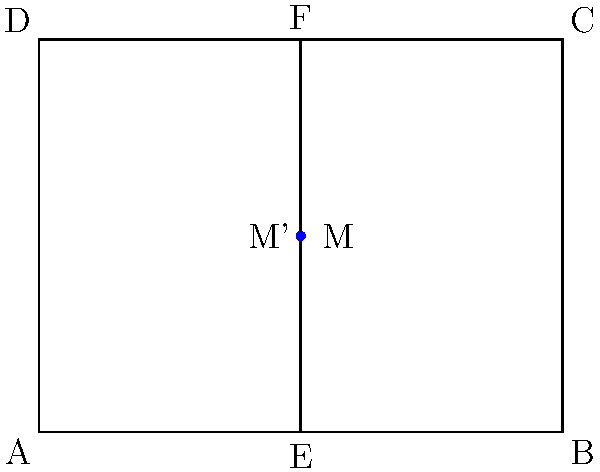A symmetric trade show logo design is represented by a rectangle ABCD with dimensions 4 units wide and 3 units tall. Point M is located at coordinates (2, 1.5) within the rectangle. If the logo is reflected across the vertical line EF that bisects the rectangle, what are the coordinates of the reflected point M'? To solve this problem, we'll follow these steps:

1) First, we need to understand that reflection across a vertical line changes the x-coordinate while keeping the y-coordinate the same.

2) The vertical line EF bisects the rectangle, so it's located at x = 2.

3) The original point M is at (2, 1.5).

4) To reflect M across the line x = 2, we need to find a point that is as far to the right of the line as M is to the left.

5) The distance of M from the line is:
   $2 - 2 = 0$

6) So, the reflected point M' will be this same distance to the right of the line:
   $2 + 0 = 2$

7) The y-coordinate remains unchanged at 1.5.

Therefore, the coordinates of the reflected point M' are (2, 1.5), which are the same as the original point M. This is because M is on the line of reflection, so it reflects onto itself.
Answer: (2, 1.5) 